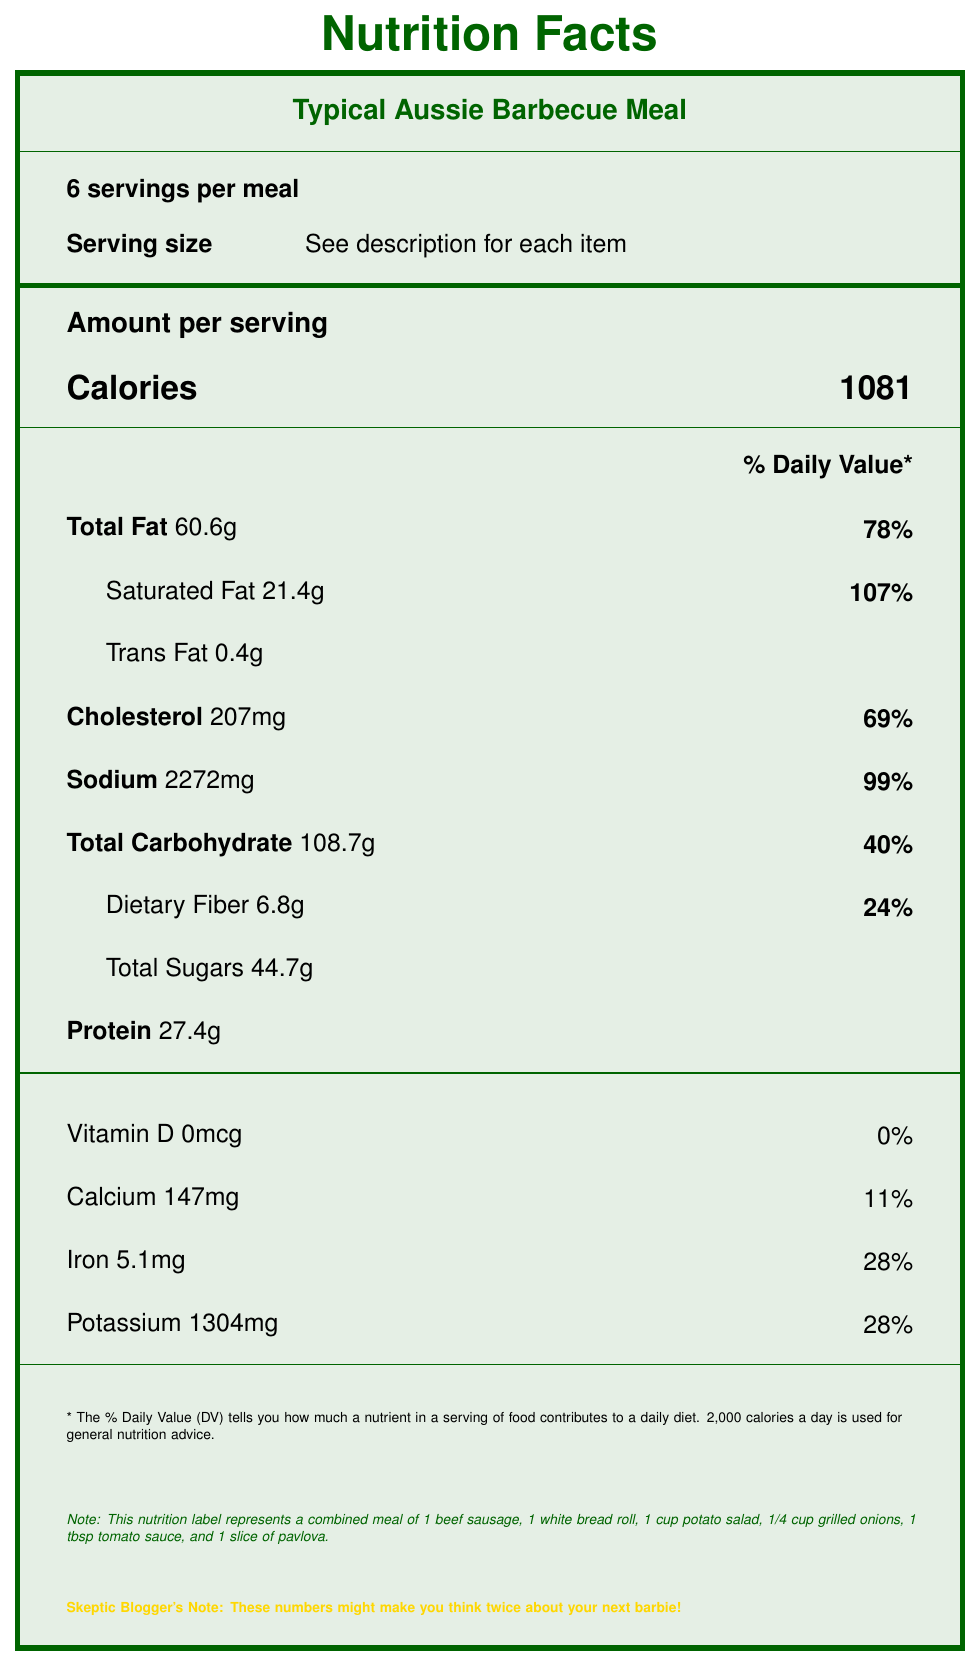how many servings per meal are specified? The document notes "**6 servings per meal**" under the "Servings info" section.
Answer: 6 servings what is the total calorie count of the meal? The "Amount per serving" section lists the total calorie count as **1081**.
Answer: 1081 calories which meal component contains the highest amount of sodium? A. Beef sausage B. White bread roll C. Potato salad D. Grilled onions The sodium content is highest in the potato salad, which has **1150mg** of sodium.
Answer: C. Potato salad how much protein is in a single serving of the meal? The "Amount per serving" section lists protein content as **27.4g**.
Answer: 27.4g does the meal contain any vitamin D? The document lists vitamin D content as **0mcg**, indicating no vitamin D.
Answer: No what percentage of the daily value for saturated fat is in the meal? The "Saturated Fat" value is **21.4g**, which is **107%** of the daily value.
Answer: 107% how much dietary fiber is in one serving of the entire meal? The "Amount per serving" section lists dietary fiber as **6.8g**.
Answer: 6.8g what is the serving size for the beef sausage? Under the meal components, "Beef sausage" has a serving size of **1 sausage (85g)**.
Answer: 1 sausage (85g) identify the least calorie-dense component of the meal. The tomato sauce has only **17 calories** per serving, making it the least calorie-dense component.
Answer: Tomato sauce what is the percentage of daily value for iron in a serving of the meal? The "Iron" value in the "Amount per serving" section is **28%**.
Answer: 28% which component has the highest amount of total sugars? A. Beef sausage B. White bread roll C. Pavlova D. Grilled onions Pavlova has the highest amount of total sugars with **35.2g**.
Answer: C. Pavlova which component is entirely free of dietary fiber? The dietary fiber content for beef sausage is listed as **0g**.
Answer: Beef sausage is the total carbohydrate count of the meal higher than the recommended daily value? The total carbohydrate count is **108.7g**, which is listed as **40%** of the daily value. The recommended daily value is **270g**.
Answer: No summarize the primary nutritional concerns highlighted in the document. The document emphasizes the meal's high levels of calories, sodium, and saturated fat while noting the absence of vitamin D and the relatively moderate amount of dietary fiber.
Answer: High in calories, sodium, and saturated fat; very little vitamin D; small amount of dietary fiber. how much calcium is in the entire meal? The "Calcium" content in the "Amount per serving" section is **147mg**.
Answer: 147mg can the document tell us the origins of the sausages? The document provides nutritional information but does not include details about the origin of the sausages.
Answer: Not enough information how many grams of sugar does the entire meal contain? The "Total Sugars" content in the "Amount per serving" section is **44.7g**.
Answer: 44.7g what is the main idea of the document? The document breaks down the nutrient composition of a typical barbeque, revealing its high calorie and nutrient contents and pointing out nutritional deficiencies, likely to prompt readers to reconsider indulging in such a meal.
Answer: The document provides detailed nutritional information for a typical Aussie barbecue meal, emphasizing its high calorie, fat, sodium, and sugar content, while also highlighting the lack of certain nutrients. 